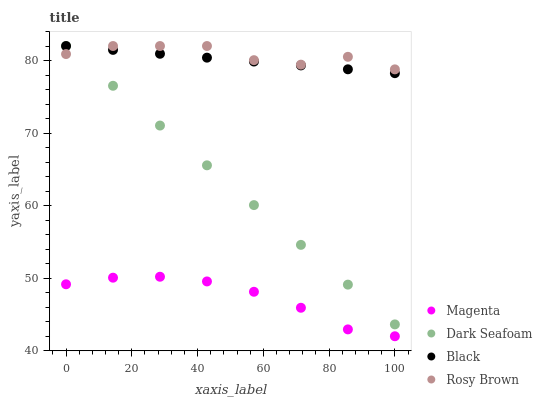Does Magenta have the minimum area under the curve?
Answer yes or no. Yes. Does Rosy Brown have the maximum area under the curve?
Answer yes or no. Yes. Does Black have the minimum area under the curve?
Answer yes or no. No. Does Black have the maximum area under the curve?
Answer yes or no. No. Is Black the smoothest?
Answer yes or no. Yes. Is Rosy Brown the roughest?
Answer yes or no. Yes. Is Rosy Brown the smoothest?
Answer yes or no. No. Is Black the roughest?
Answer yes or no. No. Does Magenta have the lowest value?
Answer yes or no. Yes. Does Black have the lowest value?
Answer yes or no. No. Does Dark Seafoam have the highest value?
Answer yes or no. Yes. Is Magenta less than Black?
Answer yes or no. Yes. Is Rosy Brown greater than Magenta?
Answer yes or no. Yes. Does Rosy Brown intersect Black?
Answer yes or no. Yes. Is Rosy Brown less than Black?
Answer yes or no. No. Is Rosy Brown greater than Black?
Answer yes or no. No. Does Magenta intersect Black?
Answer yes or no. No. 